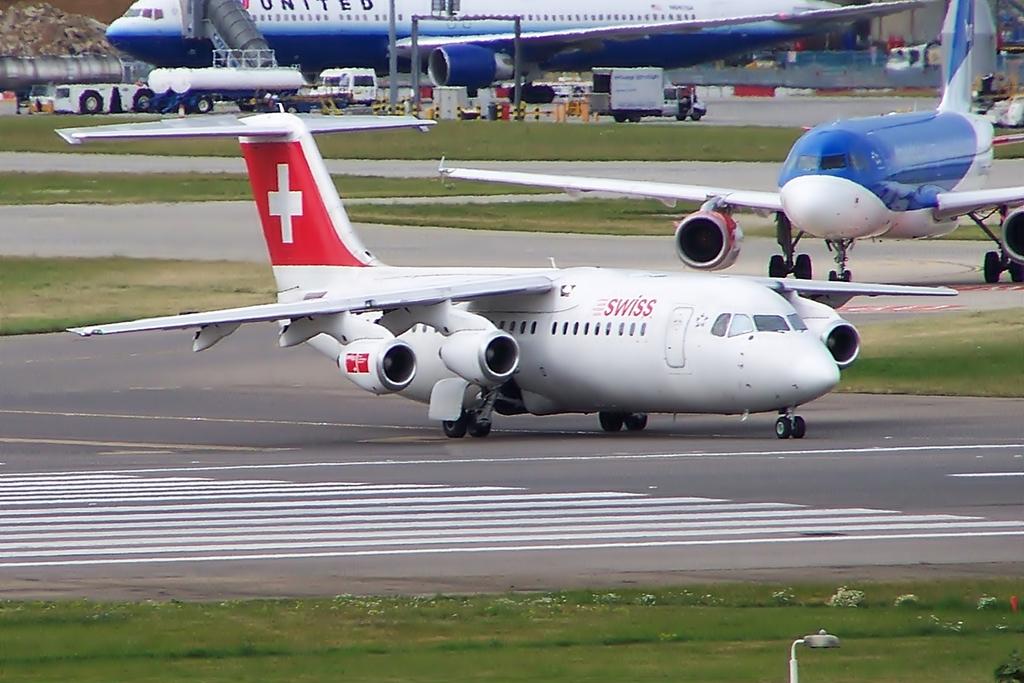What country is this airline from?
Provide a succinct answer. Switzerland . What airline is in the back?
Make the answer very short. United. 